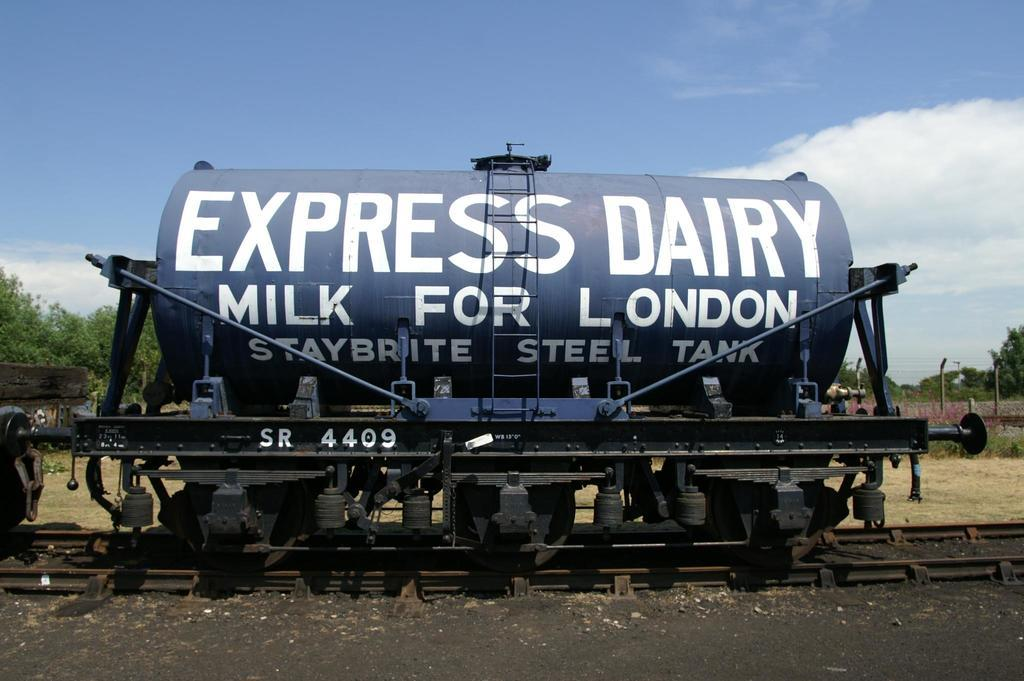What is located on the railway track in the image? There is a tank on the railway track in the image. What can be seen in the background of the image? There are trees, fencing, and a wall visible in the background. What is the color of the sky in the image? The sky is blue and white in color in the image. How does the zephyr affect the movement of the tank in the image? There is no mention of a zephyr in the image, and therefore its effect on the tank cannot be determined. 